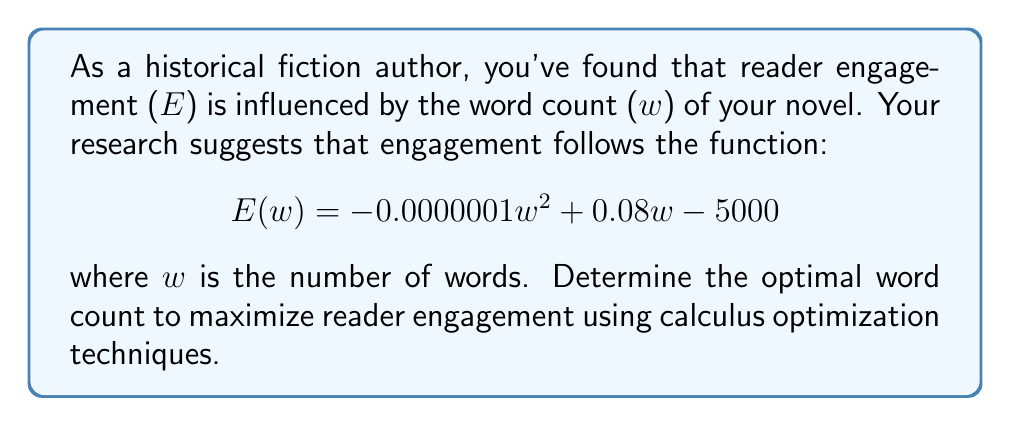Can you answer this question? To find the optimal word count that maximizes reader engagement, we need to find the maximum of the function $E(w)$. We can do this by following these steps:

1. Find the derivative of $E(w)$ with respect to $w$:
   $$E'(w) = -0.0000002w + 0.08$$

2. Set the derivative equal to zero and solve for $w$:
   $$-0.0000002w + 0.08 = 0$$
   $$-0.0000002w = -0.08$$
   $$w = \frac{-0.08}{-0.0000002} = 400,000$$

3. Verify that this critical point is a maximum by checking the second derivative:
   $$E''(w) = -0.0000002$$
   Since $E''(w)$ is negative, the critical point is indeed a maximum.

4. Round the result to the nearest thousand words, as is common in novel writing:
   $$400,000 \approx 400,000 \text{ words}$$

Therefore, the optimal word count to maximize reader engagement is approximately 400,000 words.
Answer: 400,000 words 